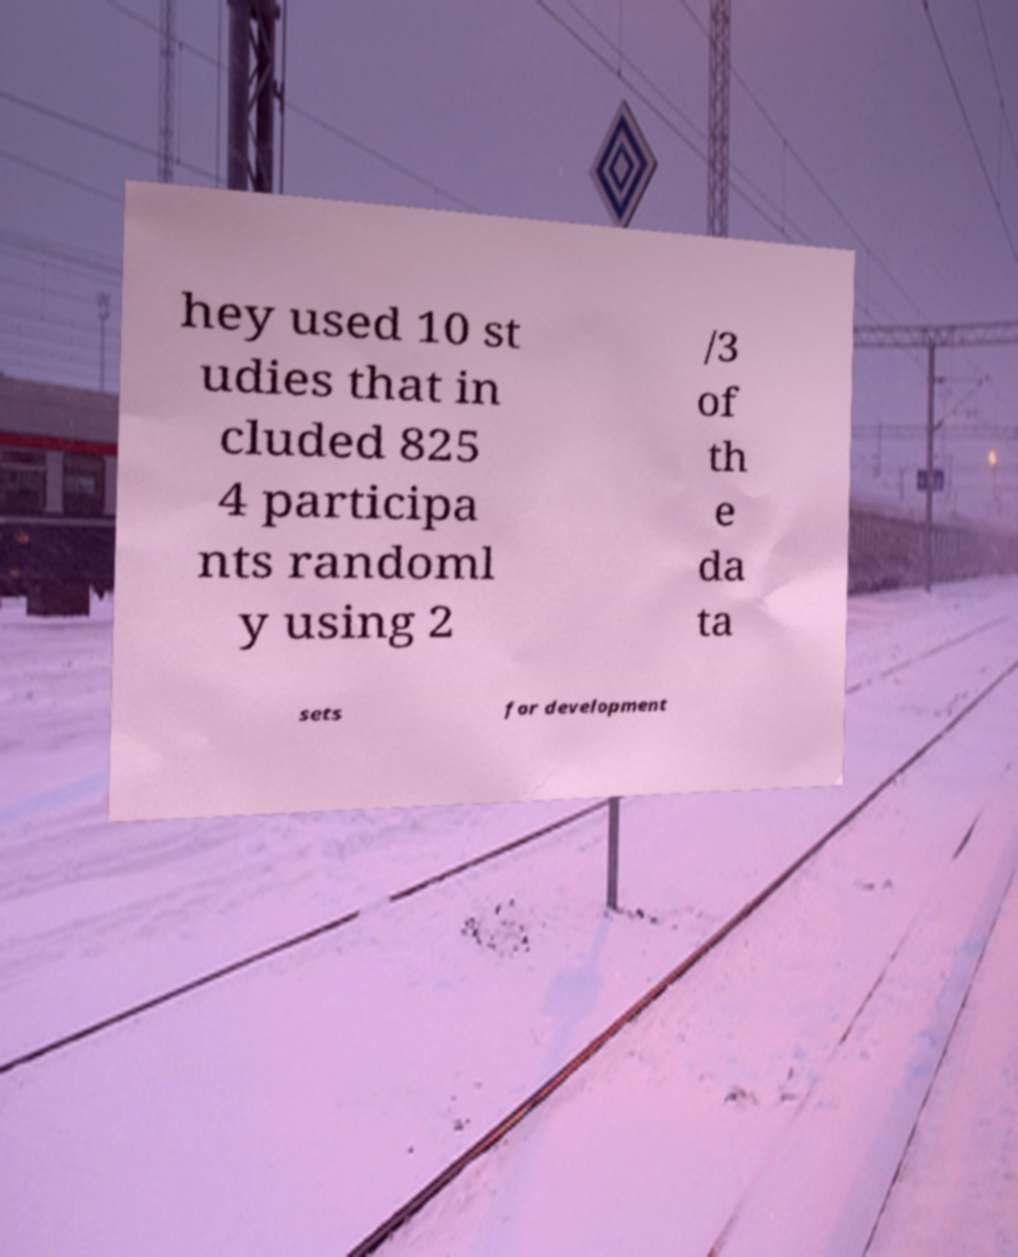What messages or text are displayed in this image? I need them in a readable, typed format. hey used 10 st udies that in cluded 825 4 participa nts randoml y using 2 /3 of th e da ta sets for development 